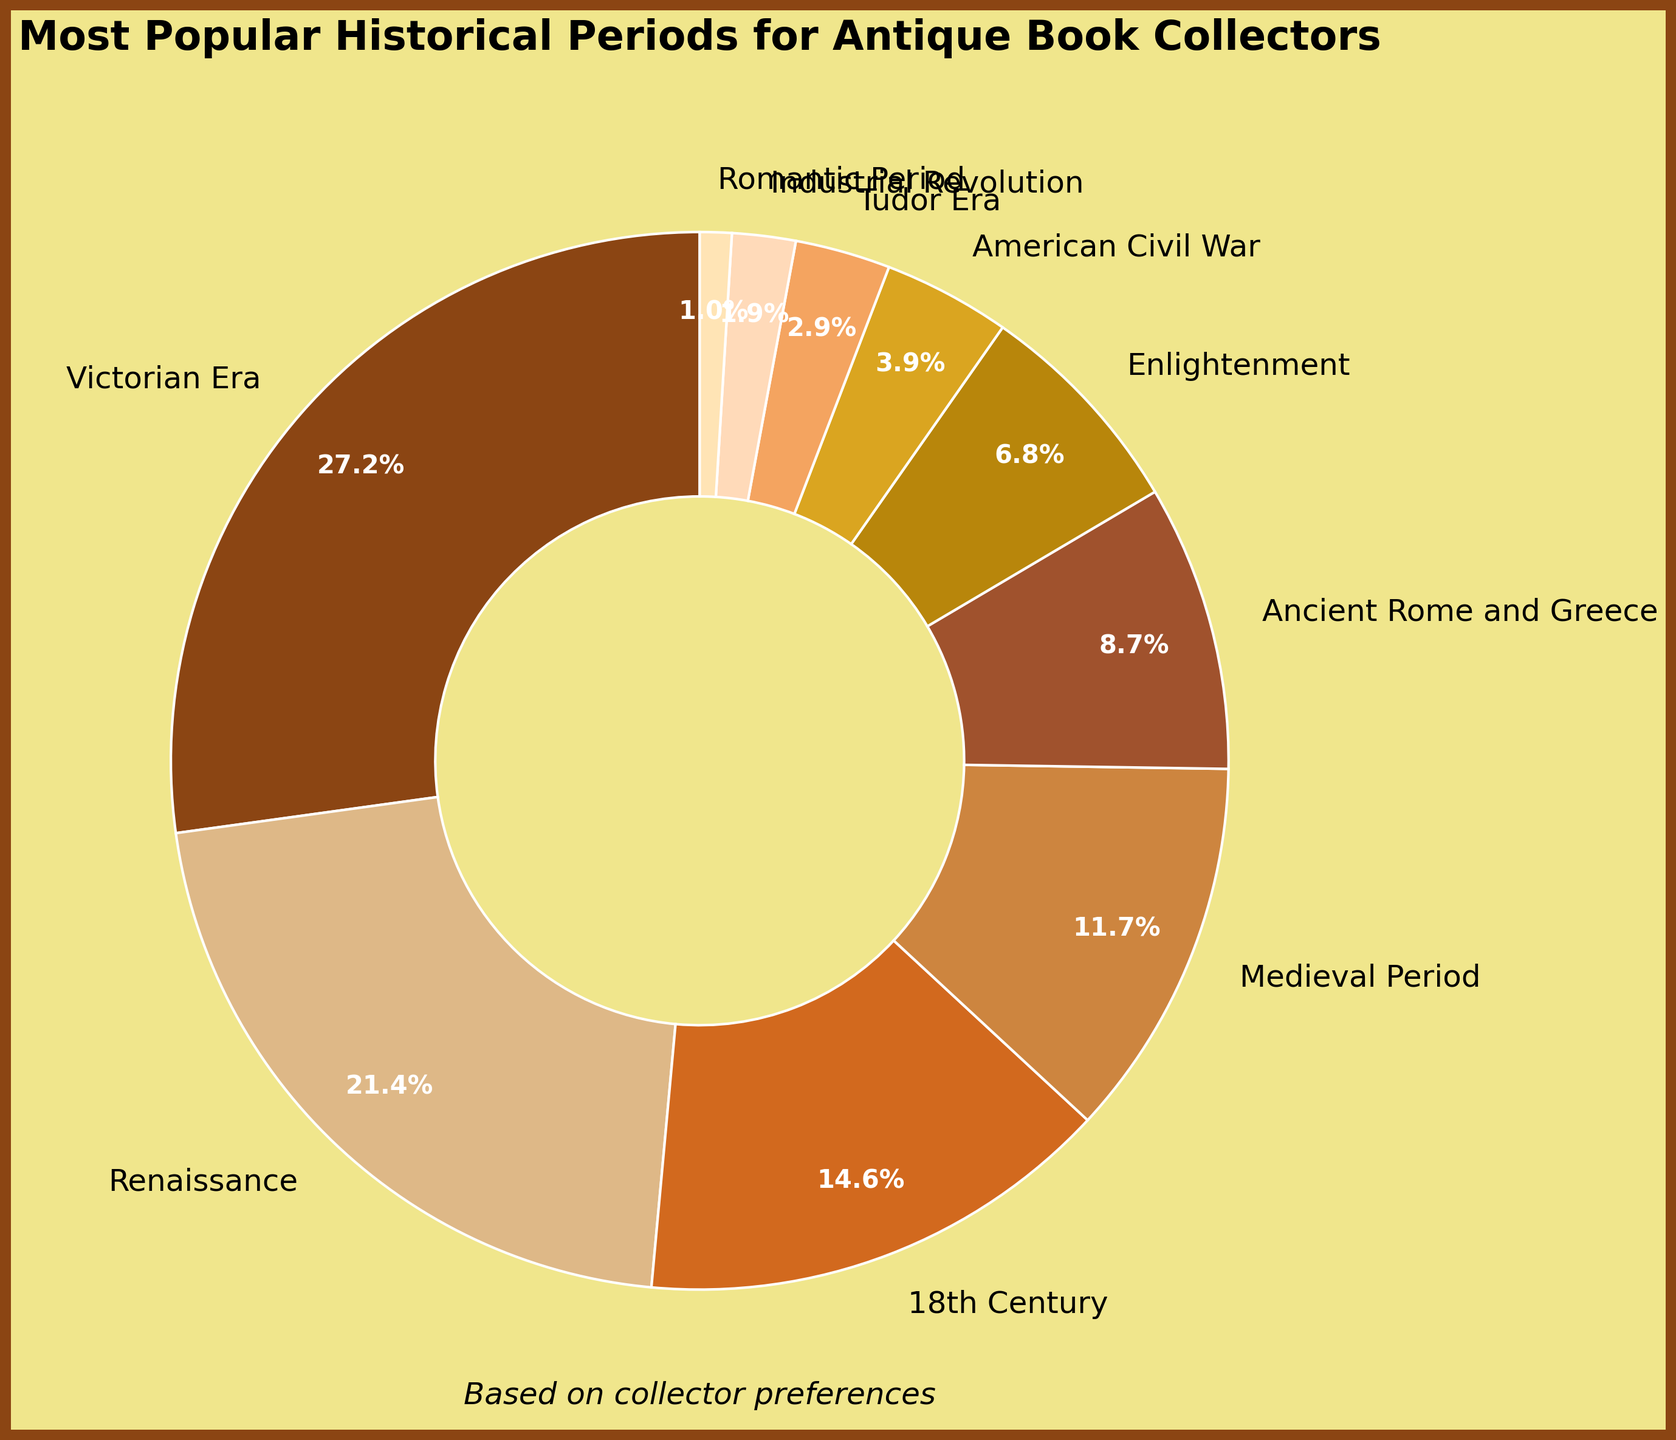What's the most popular historical period for antique book collectors? The largest section of the pie chart represents the most popular historical period. The Victorian Era has the largest portion labeled with 28%.
Answer: Victorian Era What is the total percentage for the periods Renaissance and 18th Century combined? Identify and add the percentages for both the Renaissance and 18th Century. The Renaissance is 22% and the 18th Century is 15%, so their combined percentage is 22 + 15 = 37%.
Answer: 37% Which period is less popular, Medieval Period or American Civil War? Compare the percentages for the Medieval Period and American Civil War. The Medieval Period is 12% and the American Civil War is 4%. 4% is less than 12%.
Answer: American Civil War How much more popular is the Enlightenment period than the Industrial Revolution period? Find the difference in their percentages. The Enlightenment period is 7% and the Industrial Revolution period is 2%. The difference is 7 - 2 = 5%.
Answer: 5% Which is the smallest segment in the pie chart? The smallest segment is the one with the lowest percentage value, which is the Romantic Period with 1%.
Answer: Romantic Period If we sum the percentages of the top three periods, what would the total be? Identify the top three periods: Victorian Era (28%), Renaissance (22%), and 18th Century (15%). Their total is 28 + 22 + 15 = 65%.
Answer: 65% What percentage does the period Ancient Rome and Greece account for? The pie chart segment labeled Ancient Rome and Greece shows 9%.
Answer: 9% How does the size of the Medieval Period compare to the size of the Tudor Era in the pie chart? Compare their percentages; the Medieval Period is 12% and the Tudor Era is 3%. The Medieval Period is larger.
Answer: Medieval Period is larger What is the combined percentage of periods with less than 10% popularity? Identify the periods with less than 10%: Ancient Rome and Greece (9%), Enlightenment (7%), American Civil War (4%), Tudor Era (3%), Industrial Revolution (2%), Romantic Period (1%). Sum their percentages: 9 + 7 + 4 + 3 + 2 + 1 = 26%.
Answer: 26% How many periods have a popularity of 5% or more? Count the segments in the pie chart with percentages 5% or higher. They are Victorian Era (28%), Renaissance (22%), 18th Century (15%), Medieval Period (12%), Ancient Rome and Greece (9%), Enlightenment (7%). There are 6 such periods.
Answer: 6 